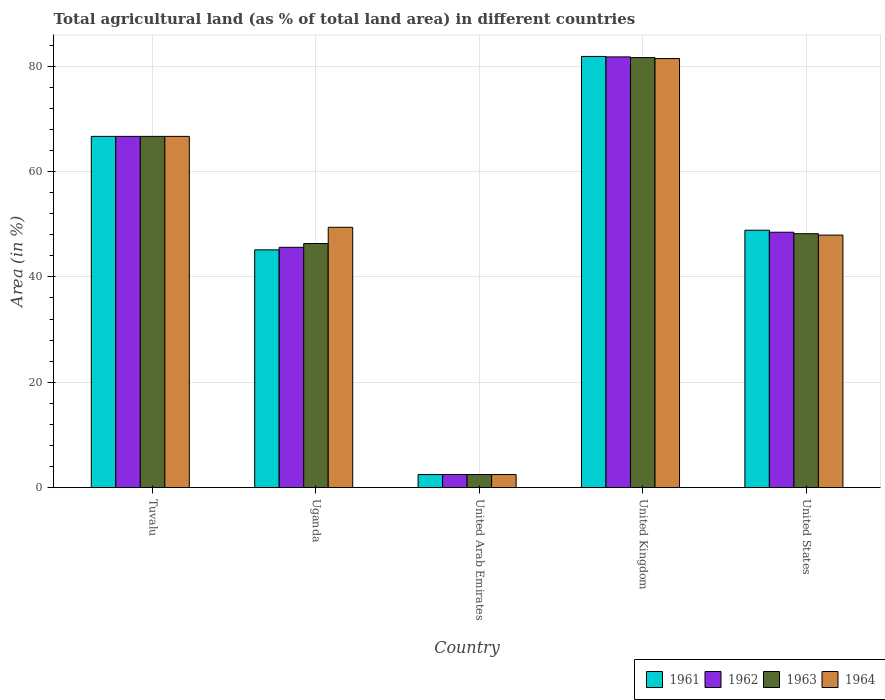Are the number of bars per tick equal to the number of legend labels?
Keep it short and to the point. Yes. Are the number of bars on each tick of the X-axis equal?
Provide a succinct answer. Yes. How many bars are there on the 4th tick from the left?
Your answer should be compact. 4. How many bars are there on the 3rd tick from the right?
Provide a succinct answer. 4. What is the label of the 1st group of bars from the left?
Your answer should be compact. Tuvalu. What is the percentage of agricultural land in 1962 in Tuvalu?
Offer a very short reply. 66.67. Across all countries, what is the maximum percentage of agricultural land in 1961?
Provide a short and direct response. 81.84. Across all countries, what is the minimum percentage of agricultural land in 1963?
Your response must be concise. 2.49. In which country was the percentage of agricultural land in 1962 maximum?
Offer a very short reply. United Kingdom. In which country was the percentage of agricultural land in 1963 minimum?
Provide a succinct answer. United Arab Emirates. What is the total percentage of agricultural land in 1964 in the graph?
Make the answer very short. 247.94. What is the difference between the percentage of agricultural land in 1961 in United Arab Emirates and that in United States?
Your answer should be compact. -46.37. What is the difference between the percentage of agricultural land in 1963 in United Arab Emirates and the percentage of agricultural land in 1964 in United States?
Give a very brief answer. -45.44. What is the average percentage of agricultural land in 1962 per country?
Offer a terse response. 49. What is the difference between the percentage of agricultural land of/in 1962 and percentage of agricultural land of/in 1963 in United Arab Emirates?
Your answer should be very brief. 0. In how many countries, is the percentage of agricultural land in 1963 greater than 44 %?
Provide a short and direct response. 4. What is the ratio of the percentage of agricultural land in 1963 in United Arab Emirates to that in United Kingdom?
Your answer should be compact. 0.03. Is the difference between the percentage of agricultural land in 1962 in Tuvalu and United Kingdom greater than the difference between the percentage of agricultural land in 1963 in Tuvalu and United Kingdom?
Keep it short and to the point. No. What is the difference between the highest and the second highest percentage of agricultural land in 1962?
Ensure brevity in your answer.  -33.28. What is the difference between the highest and the lowest percentage of agricultural land in 1962?
Provide a succinct answer. 79.27. In how many countries, is the percentage of agricultural land in 1963 greater than the average percentage of agricultural land in 1963 taken over all countries?
Your answer should be very brief. 2. Is the sum of the percentage of agricultural land in 1963 in United Arab Emirates and United Kingdom greater than the maximum percentage of agricultural land in 1962 across all countries?
Offer a terse response. Yes. Is it the case that in every country, the sum of the percentage of agricultural land in 1963 and percentage of agricultural land in 1962 is greater than the sum of percentage of agricultural land in 1964 and percentage of agricultural land in 1961?
Offer a terse response. No. Is it the case that in every country, the sum of the percentage of agricultural land in 1961 and percentage of agricultural land in 1963 is greater than the percentage of agricultural land in 1962?
Make the answer very short. Yes. How many bars are there?
Offer a very short reply. 20. Are all the bars in the graph horizontal?
Your answer should be very brief. No. How many countries are there in the graph?
Your answer should be compact. 5. What is the difference between two consecutive major ticks on the Y-axis?
Ensure brevity in your answer.  20. Are the values on the major ticks of Y-axis written in scientific E-notation?
Your answer should be very brief. No. Does the graph contain any zero values?
Your answer should be very brief. No. Does the graph contain grids?
Your response must be concise. Yes. How are the legend labels stacked?
Your response must be concise. Horizontal. What is the title of the graph?
Provide a succinct answer. Total agricultural land (as % of total land area) in different countries. What is the label or title of the X-axis?
Your response must be concise. Country. What is the label or title of the Y-axis?
Keep it short and to the point. Area (in %). What is the Area (in %) of 1961 in Tuvalu?
Give a very brief answer. 66.67. What is the Area (in %) of 1962 in Tuvalu?
Give a very brief answer. 66.67. What is the Area (in %) of 1963 in Tuvalu?
Offer a very short reply. 66.67. What is the Area (in %) of 1964 in Tuvalu?
Your answer should be very brief. 66.67. What is the Area (in %) of 1961 in Uganda?
Give a very brief answer. 45.13. What is the Area (in %) of 1962 in Uganda?
Keep it short and to the point. 45.61. What is the Area (in %) in 1963 in Uganda?
Keep it short and to the point. 46.33. What is the Area (in %) in 1964 in Uganda?
Your response must be concise. 49.41. What is the Area (in %) in 1961 in United Arab Emirates?
Your response must be concise. 2.49. What is the Area (in %) of 1962 in United Arab Emirates?
Provide a short and direct response. 2.49. What is the Area (in %) of 1963 in United Arab Emirates?
Provide a succinct answer. 2.49. What is the Area (in %) in 1964 in United Arab Emirates?
Keep it short and to the point. 2.49. What is the Area (in %) of 1961 in United Kingdom?
Ensure brevity in your answer.  81.84. What is the Area (in %) of 1962 in United Kingdom?
Provide a succinct answer. 81.76. What is the Area (in %) of 1963 in United Kingdom?
Your answer should be very brief. 81.62. What is the Area (in %) of 1964 in United Kingdom?
Ensure brevity in your answer.  81.44. What is the Area (in %) of 1961 in United States?
Offer a very short reply. 48.86. What is the Area (in %) in 1962 in United States?
Your response must be concise. 48.48. What is the Area (in %) in 1963 in United States?
Keep it short and to the point. 48.2. What is the Area (in %) of 1964 in United States?
Give a very brief answer. 47.93. Across all countries, what is the maximum Area (in %) of 1961?
Your response must be concise. 81.84. Across all countries, what is the maximum Area (in %) in 1962?
Your answer should be very brief. 81.76. Across all countries, what is the maximum Area (in %) of 1963?
Your answer should be very brief. 81.62. Across all countries, what is the maximum Area (in %) in 1964?
Your answer should be very brief. 81.44. Across all countries, what is the minimum Area (in %) of 1961?
Your answer should be compact. 2.49. Across all countries, what is the minimum Area (in %) of 1962?
Your response must be concise. 2.49. Across all countries, what is the minimum Area (in %) of 1963?
Provide a short and direct response. 2.49. Across all countries, what is the minimum Area (in %) of 1964?
Give a very brief answer. 2.49. What is the total Area (in %) in 1961 in the graph?
Keep it short and to the point. 244.99. What is the total Area (in %) of 1962 in the graph?
Offer a terse response. 245. What is the total Area (in %) in 1963 in the graph?
Keep it short and to the point. 245.31. What is the total Area (in %) in 1964 in the graph?
Make the answer very short. 247.94. What is the difference between the Area (in %) in 1961 in Tuvalu and that in Uganda?
Give a very brief answer. 21.53. What is the difference between the Area (in %) of 1962 in Tuvalu and that in Uganda?
Provide a short and direct response. 21.05. What is the difference between the Area (in %) of 1963 in Tuvalu and that in Uganda?
Offer a very short reply. 20.33. What is the difference between the Area (in %) of 1964 in Tuvalu and that in Uganda?
Ensure brevity in your answer.  17.25. What is the difference between the Area (in %) of 1961 in Tuvalu and that in United Arab Emirates?
Provide a short and direct response. 64.18. What is the difference between the Area (in %) in 1962 in Tuvalu and that in United Arab Emirates?
Your response must be concise. 64.18. What is the difference between the Area (in %) of 1963 in Tuvalu and that in United Arab Emirates?
Provide a succinct answer. 64.18. What is the difference between the Area (in %) in 1964 in Tuvalu and that in United Arab Emirates?
Your answer should be very brief. 64.18. What is the difference between the Area (in %) in 1961 in Tuvalu and that in United Kingdom?
Provide a succinct answer. -15.18. What is the difference between the Area (in %) of 1962 in Tuvalu and that in United Kingdom?
Keep it short and to the point. -15.09. What is the difference between the Area (in %) of 1963 in Tuvalu and that in United Kingdom?
Offer a terse response. -14.96. What is the difference between the Area (in %) in 1964 in Tuvalu and that in United Kingdom?
Make the answer very short. -14.77. What is the difference between the Area (in %) of 1961 in Tuvalu and that in United States?
Provide a succinct answer. 17.81. What is the difference between the Area (in %) of 1962 in Tuvalu and that in United States?
Offer a terse response. 18.19. What is the difference between the Area (in %) in 1963 in Tuvalu and that in United States?
Your response must be concise. 18.47. What is the difference between the Area (in %) in 1964 in Tuvalu and that in United States?
Your response must be concise. 18.73. What is the difference between the Area (in %) of 1961 in Uganda and that in United Arab Emirates?
Make the answer very short. 42.64. What is the difference between the Area (in %) of 1962 in Uganda and that in United Arab Emirates?
Your response must be concise. 43.13. What is the difference between the Area (in %) of 1963 in Uganda and that in United Arab Emirates?
Give a very brief answer. 43.85. What is the difference between the Area (in %) in 1964 in Uganda and that in United Arab Emirates?
Your response must be concise. 46.92. What is the difference between the Area (in %) in 1961 in Uganda and that in United Kingdom?
Your answer should be compact. -36.71. What is the difference between the Area (in %) in 1962 in Uganda and that in United Kingdom?
Make the answer very short. -36.14. What is the difference between the Area (in %) in 1963 in Uganda and that in United Kingdom?
Ensure brevity in your answer.  -35.29. What is the difference between the Area (in %) of 1964 in Uganda and that in United Kingdom?
Offer a very short reply. -32.03. What is the difference between the Area (in %) of 1961 in Uganda and that in United States?
Provide a short and direct response. -3.73. What is the difference between the Area (in %) of 1962 in Uganda and that in United States?
Provide a short and direct response. -2.86. What is the difference between the Area (in %) of 1963 in Uganda and that in United States?
Offer a terse response. -1.86. What is the difference between the Area (in %) of 1964 in Uganda and that in United States?
Provide a short and direct response. 1.48. What is the difference between the Area (in %) in 1961 in United Arab Emirates and that in United Kingdom?
Give a very brief answer. -79.35. What is the difference between the Area (in %) of 1962 in United Arab Emirates and that in United Kingdom?
Your response must be concise. -79.27. What is the difference between the Area (in %) of 1963 in United Arab Emirates and that in United Kingdom?
Provide a succinct answer. -79.13. What is the difference between the Area (in %) in 1964 in United Arab Emirates and that in United Kingdom?
Your response must be concise. -78.95. What is the difference between the Area (in %) in 1961 in United Arab Emirates and that in United States?
Give a very brief answer. -46.37. What is the difference between the Area (in %) of 1962 in United Arab Emirates and that in United States?
Provide a succinct answer. -45.99. What is the difference between the Area (in %) of 1963 in United Arab Emirates and that in United States?
Make the answer very short. -45.71. What is the difference between the Area (in %) of 1964 in United Arab Emirates and that in United States?
Your response must be concise. -45.44. What is the difference between the Area (in %) of 1961 in United Kingdom and that in United States?
Your answer should be compact. 32.98. What is the difference between the Area (in %) of 1962 in United Kingdom and that in United States?
Your answer should be very brief. 33.28. What is the difference between the Area (in %) in 1963 in United Kingdom and that in United States?
Provide a short and direct response. 33.42. What is the difference between the Area (in %) in 1964 in United Kingdom and that in United States?
Make the answer very short. 33.51. What is the difference between the Area (in %) of 1961 in Tuvalu and the Area (in %) of 1962 in Uganda?
Give a very brief answer. 21.05. What is the difference between the Area (in %) of 1961 in Tuvalu and the Area (in %) of 1963 in Uganda?
Keep it short and to the point. 20.33. What is the difference between the Area (in %) in 1961 in Tuvalu and the Area (in %) in 1964 in Uganda?
Ensure brevity in your answer.  17.25. What is the difference between the Area (in %) of 1962 in Tuvalu and the Area (in %) of 1963 in Uganda?
Your response must be concise. 20.33. What is the difference between the Area (in %) in 1962 in Tuvalu and the Area (in %) in 1964 in Uganda?
Make the answer very short. 17.25. What is the difference between the Area (in %) in 1963 in Tuvalu and the Area (in %) in 1964 in Uganda?
Give a very brief answer. 17.25. What is the difference between the Area (in %) of 1961 in Tuvalu and the Area (in %) of 1962 in United Arab Emirates?
Your response must be concise. 64.18. What is the difference between the Area (in %) in 1961 in Tuvalu and the Area (in %) in 1963 in United Arab Emirates?
Make the answer very short. 64.18. What is the difference between the Area (in %) in 1961 in Tuvalu and the Area (in %) in 1964 in United Arab Emirates?
Give a very brief answer. 64.18. What is the difference between the Area (in %) of 1962 in Tuvalu and the Area (in %) of 1963 in United Arab Emirates?
Offer a very short reply. 64.18. What is the difference between the Area (in %) in 1962 in Tuvalu and the Area (in %) in 1964 in United Arab Emirates?
Your answer should be very brief. 64.18. What is the difference between the Area (in %) in 1963 in Tuvalu and the Area (in %) in 1964 in United Arab Emirates?
Make the answer very short. 64.18. What is the difference between the Area (in %) in 1961 in Tuvalu and the Area (in %) in 1962 in United Kingdom?
Provide a short and direct response. -15.09. What is the difference between the Area (in %) of 1961 in Tuvalu and the Area (in %) of 1963 in United Kingdom?
Your answer should be compact. -14.96. What is the difference between the Area (in %) in 1961 in Tuvalu and the Area (in %) in 1964 in United Kingdom?
Offer a very short reply. -14.77. What is the difference between the Area (in %) in 1962 in Tuvalu and the Area (in %) in 1963 in United Kingdom?
Provide a succinct answer. -14.96. What is the difference between the Area (in %) of 1962 in Tuvalu and the Area (in %) of 1964 in United Kingdom?
Give a very brief answer. -14.77. What is the difference between the Area (in %) in 1963 in Tuvalu and the Area (in %) in 1964 in United Kingdom?
Your answer should be very brief. -14.77. What is the difference between the Area (in %) of 1961 in Tuvalu and the Area (in %) of 1962 in United States?
Provide a short and direct response. 18.19. What is the difference between the Area (in %) in 1961 in Tuvalu and the Area (in %) in 1963 in United States?
Your answer should be compact. 18.47. What is the difference between the Area (in %) in 1961 in Tuvalu and the Area (in %) in 1964 in United States?
Give a very brief answer. 18.73. What is the difference between the Area (in %) of 1962 in Tuvalu and the Area (in %) of 1963 in United States?
Keep it short and to the point. 18.47. What is the difference between the Area (in %) of 1962 in Tuvalu and the Area (in %) of 1964 in United States?
Provide a succinct answer. 18.73. What is the difference between the Area (in %) of 1963 in Tuvalu and the Area (in %) of 1964 in United States?
Keep it short and to the point. 18.73. What is the difference between the Area (in %) in 1961 in Uganda and the Area (in %) in 1962 in United Arab Emirates?
Offer a very short reply. 42.64. What is the difference between the Area (in %) in 1961 in Uganda and the Area (in %) in 1963 in United Arab Emirates?
Offer a very short reply. 42.64. What is the difference between the Area (in %) of 1961 in Uganda and the Area (in %) of 1964 in United Arab Emirates?
Your answer should be compact. 42.64. What is the difference between the Area (in %) in 1962 in Uganda and the Area (in %) in 1963 in United Arab Emirates?
Your response must be concise. 43.13. What is the difference between the Area (in %) of 1962 in Uganda and the Area (in %) of 1964 in United Arab Emirates?
Ensure brevity in your answer.  43.13. What is the difference between the Area (in %) of 1963 in Uganda and the Area (in %) of 1964 in United Arab Emirates?
Provide a short and direct response. 43.85. What is the difference between the Area (in %) in 1961 in Uganda and the Area (in %) in 1962 in United Kingdom?
Provide a succinct answer. -36.62. What is the difference between the Area (in %) of 1961 in Uganda and the Area (in %) of 1963 in United Kingdom?
Give a very brief answer. -36.49. What is the difference between the Area (in %) of 1961 in Uganda and the Area (in %) of 1964 in United Kingdom?
Ensure brevity in your answer.  -36.31. What is the difference between the Area (in %) in 1962 in Uganda and the Area (in %) in 1963 in United Kingdom?
Provide a succinct answer. -36.01. What is the difference between the Area (in %) in 1962 in Uganda and the Area (in %) in 1964 in United Kingdom?
Provide a short and direct response. -35.83. What is the difference between the Area (in %) of 1963 in Uganda and the Area (in %) of 1964 in United Kingdom?
Give a very brief answer. -35.11. What is the difference between the Area (in %) in 1961 in Uganda and the Area (in %) in 1962 in United States?
Your answer should be very brief. -3.34. What is the difference between the Area (in %) in 1961 in Uganda and the Area (in %) in 1963 in United States?
Your answer should be very brief. -3.07. What is the difference between the Area (in %) in 1961 in Uganda and the Area (in %) in 1964 in United States?
Make the answer very short. -2.8. What is the difference between the Area (in %) in 1962 in Uganda and the Area (in %) in 1963 in United States?
Offer a terse response. -2.58. What is the difference between the Area (in %) of 1962 in Uganda and the Area (in %) of 1964 in United States?
Keep it short and to the point. -2.32. What is the difference between the Area (in %) of 1963 in Uganda and the Area (in %) of 1964 in United States?
Your answer should be very brief. -1.6. What is the difference between the Area (in %) in 1961 in United Arab Emirates and the Area (in %) in 1962 in United Kingdom?
Your response must be concise. -79.27. What is the difference between the Area (in %) in 1961 in United Arab Emirates and the Area (in %) in 1963 in United Kingdom?
Offer a terse response. -79.13. What is the difference between the Area (in %) in 1961 in United Arab Emirates and the Area (in %) in 1964 in United Kingdom?
Make the answer very short. -78.95. What is the difference between the Area (in %) of 1962 in United Arab Emirates and the Area (in %) of 1963 in United Kingdom?
Provide a succinct answer. -79.13. What is the difference between the Area (in %) in 1962 in United Arab Emirates and the Area (in %) in 1964 in United Kingdom?
Your response must be concise. -78.95. What is the difference between the Area (in %) in 1963 in United Arab Emirates and the Area (in %) in 1964 in United Kingdom?
Your answer should be very brief. -78.95. What is the difference between the Area (in %) of 1961 in United Arab Emirates and the Area (in %) of 1962 in United States?
Your response must be concise. -45.99. What is the difference between the Area (in %) in 1961 in United Arab Emirates and the Area (in %) in 1963 in United States?
Your answer should be compact. -45.71. What is the difference between the Area (in %) in 1961 in United Arab Emirates and the Area (in %) in 1964 in United States?
Offer a terse response. -45.44. What is the difference between the Area (in %) of 1962 in United Arab Emirates and the Area (in %) of 1963 in United States?
Offer a terse response. -45.71. What is the difference between the Area (in %) of 1962 in United Arab Emirates and the Area (in %) of 1964 in United States?
Give a very brief answer. -45.44. What is the difference between the Area (in %) of 1963 in United Arab Emirates and the Area (in %) of 1964 in United States?
Offer a terse response. -45.44. What is the difference between the Area (in %) of 1961 in United Kingdom and the Area (in %) of 1962 in United States?
Ensure brevity in your answer.  33.37. What is the difference between the Area (in %) in 1961 in United Kingdom and the Area (in %) in 1963 in United States?
Your answer should be very brief. 33.64. What is the difference between the Area (in %) in 1961 in United Kingdom and the Area (in %) in 1964 in United States?
Keep it short and to the point. 33.91. What is the difference between the Area (in %) in 1962 in United Kingdom and the Area (in %) in 1963 in United States?
Make the answer very short. 33.56. What is the difference between the Area (in %) of 1962 in United Kingdom and the Area (in %) of 1964 in United States?
Make the answer very short. 33.82. What is the difference between the Area (in %) of 1963 in United Kingdom and the Area (in %) of 1964 in United States?
Ensure brevity in your answer.  33.69. What is the average Area (in %) of 1961 per country?
Offer a very short reply. 49. What is the average Area (in %) of 1962 per country?
Offer a very short reply. 49. What is the average Area (in %) in 1963 per country?
Provide a succinct answer. 49.06. What is the average Area (in %) in 1964 per country?
Your answer should be very brief. 49.59. What is the difference between the Area (in %) of 1961 and Area (in %) of 1962 in Tuvalu?
Provide a succinct answer. 0. What is the difference between the Area (in %) in 1961 and Area (in %) in 1963 in Tuvalu?
Your response must be concise. 0. What is the difference between the Area (in %) in 1962 and Area (in %) in 1963 in Tuvalu?
Ensure brevity in your answer.  0. What is the difference between the Area (in %) of 1962 and Area (in %) of 1964 in Tuvalu?
Keep it short and to the point. 0. What is the difference between the Area (in %) of 1963 and Area (in %) of 1964 in Tuvalu?
Ensure brevity in your answer.  0. What is the difference between the Area (in %) in 1961 and Area (in %) in 1962 in Uganda?
Your answer should be very brief. -0.48. What is the difference between the Area (in %) in 1961 and Area (in %) in 1963 in Uganda?
Your answer should be compact. -1.2. What is the difference between the Area (in %) in 1961 and Area (in %) in 1964 in Uganda?
Offer a terse response. -4.28. What is the difference between the Area (in %) in 1962 and Area (in %) in 1963 in Uganda?
Provide a succinct answer. -0.72. What is the difference between the Area (in %) in 1962 and Area (in %) in 1964 in Uganda?
Give a very brief answer. -3.8. What is the difference between the Area (in %) in 1963 and Area (in %) in 1964 in Uganda?
Offer a very short reply. -3.08. What is the difference between the Area (in %) of 1961 and Area (in %) of 1963 in United Arab Emirates?
Provide a succinct answer. 0. What is the difference between the Area (in %) of 1961 and Area (in %) of 1964 in United Arab Emirates?
Provide a succinct answer. 0. What is the difference between the Area (in %) in 1962 and Area (in %) in 1964 in United Arab Emirates?
Your answer should be very brief. 0. What is the difference between the Area (in %) in 1961 and Area (in %) in 1962 in United Kingdom?
Make the answer very short. 0.09. What is the difference between the Area (in %) of 1961 and Area (in %) of 1963 in United Kingdom?
Give a very brief answer. 0.22. What is the difference between the Area (in %) of 1961 and Area (in %) of 1964 in United Kingdom?
Offer a very short reply. 0.4. What is the difference between the Area (in %) of 1962 and Area (in %) of 1963 in United Kingdom?
Offer a very short reply. 0.13. What is the difference between the Area (in %) in 1962 and Area (in %) in 1964 in United Kingdom?
Your answer should be very brief. 0.31. What is the difference between the Area (in %) of 1963 and Area (in %) of 1964 in United Kingdom?
Provide a short and direct response. 0.18. What is the difference between the Area (in %) in 1961 and Area (in %) in 1962 in United States?
Offer a very short reply. 0.38. What is the difference between the Area (in %) of 1961 and Area (in %) of 1963 in United States?
Offer a very short reply. 0.66. What is the difference between the Area (in %) in 1961 and Area (in %) in 1964 in United States?
Give a very brief answer. 0.93. What is the difference between the Area (in %) in 1962 and Area (in %) in 1963 in United States?
Your answer should be compact. 0.28. What is the difference between the Area (in %) of 1962 and Area (in %) of 1964 in United States?
Your answer should be very brief. 0.54. What is the difference between the Area (in %) of 1963 and Area (in %) of 1964 in United States?
Offer a very short reply. 0.27. What is the ratio of the Area (in %) in 1961 in Tuvalu to that in Uganda?
Keep it short and to the point. 1.48. What is the ratio of the Area (in %) in 1962 in Tuvalu to that in Uganda?
Offer a very short reply. 1.46. What is the ratio of the Area (in %) in 1963 in Tuvalu to that in Uganda?
Your response must be concise. 1.44. What is the ratio of the Area (in %) of 1964 in Tuvalu to that in Uganda?
Provide a succinct answer. 1.35. What is the ratio of the Area (in %) in 1961 in Tuvalu to that in United Arab Emirates?
Keep it short and to the point. 26.79. What is the ratio of the Area (in %) in 1962 in Tuvalu to that in United Arab Emirates?
Your response must be concise. 26.79. What is the ratio of the Area (in %) of 1963 in Tuvalu to that in United Arab Emirates?
Offer a terse response. 26.79. What is the ratio of the Area (in %) of 1964 in Tuvalu to that in United Arab Emirates?
Provide a succinct answer. 26.79. What is the ratio of the Area (in %) in 1961 in Tuvalu to that in United Kingdom?
Offer a very short reply. 0.81. What is the ratio of the Area (in %) in 1962 in Tuvalu to that in United Kingdom?
Provide a succinct answer. 0.82. What is the ratio of the Area (in %) of 1963 in Tuvalu to that in United Kingdom?
Your answer should be very brief. 0.82. What is the ratio of the Area (in %) in 1964 in Tuvalu to that in United Kingdom?
Offer a very short reply. 0.82. What is the ratio of the Area (in %) in 1961 in Tuvalu to that in United States?
Provide a short and direct response. 1.36. What is the ratio of the Area (in %) of 1962 in Tuvalu to that in United States?
Keep it short and to the point. 1.38. What is the ratio of the Area (in %) in 1963 in Tuvalu to that in United States?
Make the answer very short. 1.38. What is the ratio of the Area (in %) of 1964 in Tuvalu to that in United States?
Your answer should be compact. 1.39. What is the ratio of the Area (in %) in 1961 in Uganda to that in United Arab Emirates?
Provide a short and direct response. 18.14. What is the ratio of the Area (in %) of 1962 in Uganda to that in United Arab Emirates?
Keep it short and to the point. 18.33. What is the ratio of the Area (in %) in 1963 in Uganda to that in United Arab Emirates?
Make the answer very short. 18.62. What is the ratio of the Area (in %) of 1964 in Uganda to that in United Arab Emirates?
Keep it short and to the point. 19.86. What is the ratio of the Area (in %) in 1961 in Uganda to that in United Kingdom?
Offer a very short reply. 0.55. What is the ratio of the Area (in %) of 1962 in Uganda to that in United Kingdom?
Keep it short and to the point. 0.56. What is the ratio of the Area (in %) of 1963 in Uganda to that in United Kingdom?
Ensure brevity in your answer.  0.57. What is the ratio of the Area (in %) of 1964 in Uganda to that in United Kingdom?
Your answer should be very brief. 0.61. What is the ratio of the Area (in %) of 1961 in Uganda to that in United States?
Your answer should be compact. 0.92. What is the ratio of the Area (in %) of 1962 in Uganda to that in United States?
Keep it short and to the point. 0.94. What is the ratio of the Area (in %) in 1963 in Uganda to that in United States?
Ensure brevity in your answer.  0.96. What is the ratio of the Area (in %) of 1964 in Uganda to that in United States?
Make the answer very short. 1.03. What is the ratio of the Area (in %) of 1961 in United Arab Emirates to that in United Kingdom?
Provide a short and direct response. 0.03. What is the ratio of the Area (in %) of 1962 in United Arab Emirates to that in United Kingdom?
Your answer should be very brief. 0.03. What is the ratio of the Area (in %) of 1963 in United Arab Emirates to that in United Kingdom?
Your response must be concise. 0.03. What is the ratio of the Area (in %) of 1964 in United Arab Emirates to that in United Kingdom?
Provide a short and direct response. 0.03. What is the ratio of the Area (in %) in 1961 in United Arab Emirates to that in United States?
Your response must be concise. 0.05. What is the ratio of the Area (in %) of 1962 in United Arab Emirates to that in United States?
Provide a short and direct response. 0.05. What is the ratio of the Area (in %) in 1963 in United Arab Emirates to that in United States?
Provide a short and direct response. 0.05. What is the ratio of the Area (in %) in 1964 in United Arab Emirates to that in United States?
Keep it short and to the point. 0.05. What is the ratio of the Area (in %) in 1961 in United Kingdom to that in United States?
Keep it short and to the point. 1.68. What is the ratio of the Area (in %) in 1962 in United Kingdom to that in United States?
Keep it short and to the point. 1.69. What is the ratio of the Area (in %) of 1963 in United Kingdom to that in United States?
Your response must be concise. 1.69. What is the ratio of the Area (in %) of 1964 in United Kingdom to that in United States?
Offer a terse response. 1.7. What is the difference between the highest and the second highest Area (in %) of 1961?
Offer a very short reply. 15.18. What is the difference between the highest and the second highest Area (in %) in 1962?
Provide a succinct answer. 15.09. What is the difference between the highest and the second highest Area (in %) in 1963?
Offer a very short reply. 14.96. What is the difference between the highest and the second highest Area (in %) of 1964?
Offer a terse response. 14.77. What is the difference between the highest and the lowest Area (in %) of 1961?
Make the answer very short. 79.35. What is the difference between the highest and the lowest Area (in %) in 1962?
Give a very brief answer. 79.27. What is the difference between the highest and the lowest Area (in %) in 1963?
Provide a short and direct response. 79.13. What is the difference between the highest and the lowest Area (in %) of 1964?
Make the answer very short. 78.95. 